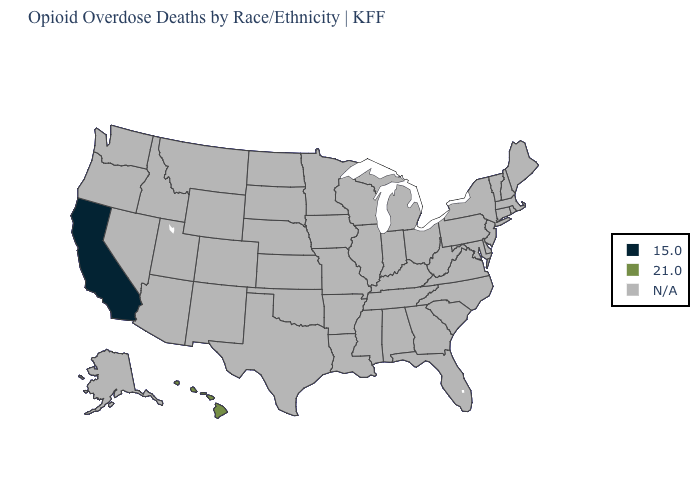What is the value of Louisiana?
Be succinct. N/A. What is the value of New York?
Keep it brief. N/A. What is the value of Alabama?
Quick response, please. N/A. What is the lowest value in the West?
Quick response, please. 15.0. What is the value of Alaska?
Be succinct. N/A. What is the highest value in the West ?
Give a very brief answer. 21.0. Does California have the highest value in the USA?
Be succinct. No. Name the states that have a value in the range 15.0?
Short answer required. California. Name the states that have a value in the range N/A?
Short answer required. Alabama, Alaska, Arizona, Arkansas, Colorado, Connecticut, Delaware, Florida, Georgia, Idaho, Illinois, Indiana, Iowa, Kansas, Kentucky, Louisiana, Maine, Maryland, Massachusetts, Michigan, Minnesota, Mississippi, Missouri, Montana, Nebraska, Nevada, New Hampshire, New Jersey, New Mexico, New York, North Carolina, North Dakota, Ohio, Oklahoma, Oregon, Pennsylvania, Rhode Island, South Carolina, South Dakota, Tennessee, Texas, Utah, Vermont, Virginia, Washington, West Virginia, Wisconsin, Wyoming. What is the value of Hawaii?
Give a very brief answer. 21.0. What is the lowest value in the USA?
Concise answer only. 15.0. Does the first symbol in the legend represent the smallest category?
Quick response, please. Yes. What is the value of Michigan?
Be succinct. N/A. What is the value of Connecticut?
Quick response, please. N/A. 